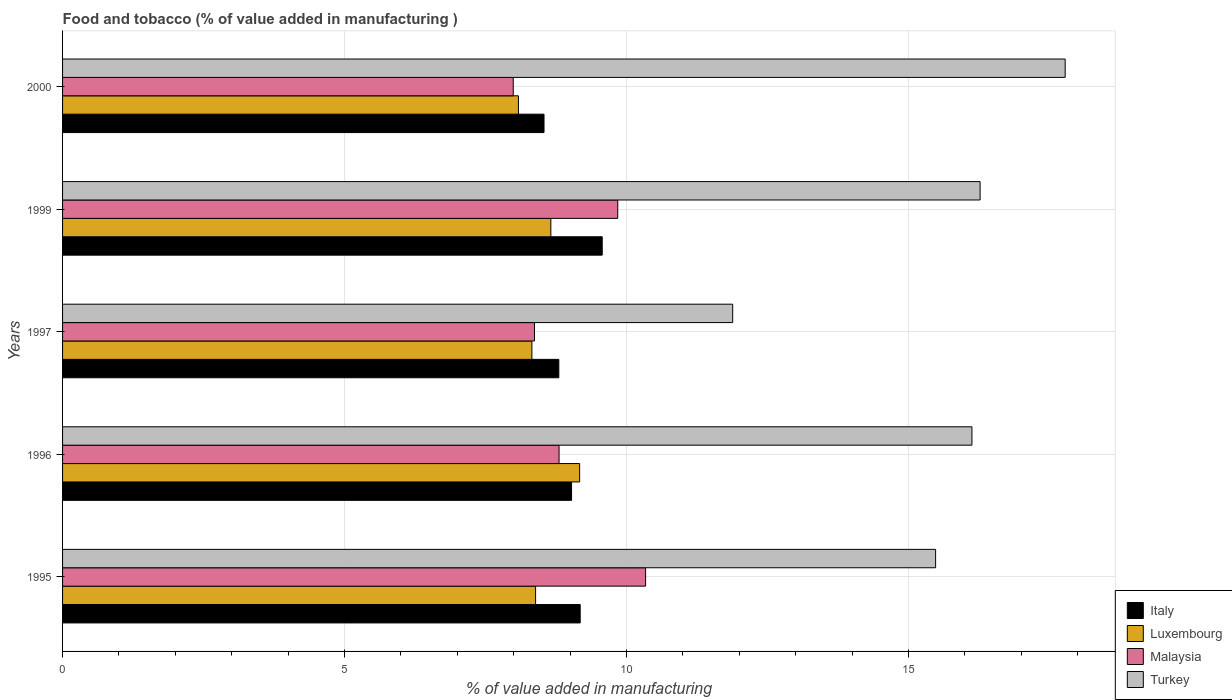How many different coloured bars are there?
Give a very brief answer. 4. How many groups of bars are there?
Offer a terse response. 5. Are the number of bars per tick equal to the number of legend labels?
Your answer should be very brief. Yes. How many bars are there on the 4th tick from the top?
Offer a very short reply. 4. How many bars are there on the 3rd tick from the bottom?
Your answer should be compact. 4. In how many cases, is the number of bars for a given year not equal to the number of legend labels?
Give a very brief answer. 0. What is the value added in manufacturing food and tobacco in Turkey in 1996?
Make the answer very short. 16.12. Across all years, what is the maximum value added in manufacturing food and tobacco in Italy?
Your answer should be compact. 9.57. Across all years, what is the minimum value added in manufacturing food and tobacco in Luxembourg?
Keep it short and to the point. 8.08. What is the total value added in manufacturing food and tobacco in Turkey in the graph?
Offer a terse response. 77.54. What is the difference between the value added in manufacturing food and tobacco in Italy in 1997 and that in 1999?
Your answer should be very brief. -0.77. What is the difference between the value added in manufacturing food and tobacco in Malaysia in 2000 and the value added in manufacturing food and tobacco in Turkey in 1995?
Your response must be concise. -7.49. What is the average value added in manufacturing food and tobacco in Turkey per year?
Ensure brevity in your answer.  15.51. In the year 1997, what is the difference between the value added in manufacturing food and tobacco in Turkey and value added in manufacturing food and tobacco in Luxembourg?
Offer a terse response. 3.56. What is the ratio of the value added in manufacturing food and tobacco in Luxembourg in 1996 to that in 1999?
Provide a succinct answer. 1.06. What is the difference between the highest and the second highest value added in manufacturing food and tobacco in Luxembourg?
Provide a succinct answer. 0.51. What is the difference between the highest and the lowest value added in manufacturing food and tobacco in Malaysia?
Keep it short and to the point. 2.35. What does the 2nd bar from the top in 1997 represents?
Provide a short and direct response. Malaysia. Are all the bars in the graph horizontal?
Provide a succinct answer. Yes. Are the values on the major ticks of X-axis written in scientific E-notation?
Ensure brevity in your answer.  No. Does the graph contain any zero values?
Provide a short and direct response. No. Does the graph contain grids?
Make the answer very short. Yes. Where does the legend appear in the graph?
Your answer should be compact. Bottom right. What is the title of the graph?
Your answer should be compact. Food and tobacco (% of value added in manufacturing ). Does "Dominica" appear as one of the legend labels in the graph?
Make the answer very short. No. What is the label or title of the X-axis?
Give a very brief answer. % of value added in manufacturing. What is the label or title of the Y-axis?
Ensure brevity in your answer.  Years. What is the % of value added in manufacturing of Italy in 1995?
Your answer should be compact. 9.18. What is the % of value added in manufacturing in Luxembourg in 1995?
Ensure brevity in your answer.  8.39. What is the % of value added in manufacturing of Malaysia in 1995?
Keep it short and to the point. 10.34. What is the % of value added in manufacturing in Turkey in 1995?
Your answer should be compact. 15.48. What is the % of value added in manufacturing in Italy in 1996?
Your answer should be compact. 9.03. What is the % of value added in manufacturing in Luxembourg in 1996?
Offer a terse response. 9.17. What is the % of value added in manufacturing of Malaysia in 1996?
Provide a succinct answer. 8.8. What is the % of value added in manufacturing of Turkey in 1996?
Ensure brevity in your answer.  16.12. What is the % of value added in manufacturing in Italy in 1997?
Make the answer very short. 8.8. What is the % of value added in manufacturing in Luxembourg in 1997?
Provide a succinct answer. 8.32. What is the % of value added in manufacturing of Malaysia in 1997?
Offer a very short reply. 8.37. What is the % of value added in manufacturing of Turkey in 1997?
Your answer should be very brief. 11.88. What is the % of value added in manufacturing in Italy in 1999?
Your answer should be compact. 9.57. What is the % of value added in manufacturing of Luxembourg in 1999?
Ensure brevity in your answer.  8.66. What is the % of value added in manufacturing of Malaysia in 1999?
Ensure brevity in your answer.  9.84. What is the % of value added in manufacturing of Turkey in 1999?
Provide a succinct answer. 16.27. What is the % of value added in manufacturing in Italy in 2000?
Your answer should be very brief. 8.54. What is the % of value added in manufacturing of Luxembourg in 2000?
Make the answer very short. 8.08. What is the % of value added in manufacturing in Malaysia in 2000?
Make the answer very short. 7.99. What is the % of value added in manufacturing of Turkey in 2000?
Your response must be concise. 17.78. Across all years, what is the maximum % of value added in manufacturing in Italy?
Provide a succinct answer. 9.57. Across all years, what is the maximum % of value added in manufacturing in Luxembourg?
Keep it short and to the point. 9.17. Across all years, what is the maximum % of value added in manufacturing in Malaysia?
Offer a very short reply. 10.34. Across all years, what is the maximum % of value added in manufacturing in Turkey?
Provide a short and direct response. 17.78. Across all years, what is the minimum % of value added in manufacturing of Italy?
Ensure brevity in your answer.  8.54. Across all years, what is the minimum % of value added in manufacturing of Luxembourg?
Your answer should be very brief. 8.08. Across all years, what is the minimum % of value added in manufacturing in Malaysia?
Keep it short and to the point. 7.99. Across all years, what is the minimum % of value added in manufacturing of Turkey?
Ensure brevity in your answer.  11.88. What is the total % of value added in manufacturing of Italy in the graph?
Your answer should be compact. 45.11. What is the total % of value added in manufacturing in Luxembourg in the graph?
Provide a succinct answer. 42.62. What is the total % of value added in manufacturing in Malaysia in the graph?
Your answer should be compact. 45.35. What is the total % of value added in manufacturing in Turkey in the graph?
Offer a very short reply. 77.54. What is the difference between the % of value added in manufacturing in Italy in 1995 and that in 1996?
Offer a terse response. 0.15. What is the difference between the % of value added in manufacturing of Luxembourg in 1995 and that in 1996?
Ensure brevity in your answer.  -0.78. What is the difference between the % of value added in manufacturing in Malaysia in 1995 and that in 1996?
Your answer should be compact. 1.53. What is the difference between the % of value added in manufacturing in Turkey in 1995 and that in 1996?
Provide a succinct answer. -0.64. What is the difference between the % of value added in manufacturing of Italy in 1995 and that in 1997?
Ensure brevity in your answer.  0.38. What is the difference between the % of value added in manufacturing of Luxembourg in 1995 and that in 1997?
Give a very brief answer. 0.07. What is the difference between the % of value added in manufacturing in Malaysia in 1995 and that in 1997?
Give a very brief answer. 1.97. What is the difference between the % of value added in manufacturing of Turkey in 1995 and that in 1997?
Make the answer very short. 3.6. What is the difference between the % of value added in manufacturing of Italy in 1995 and that in 1999?
Provide a short and direct response. -0.39. What is the difference between the % of value added in manufacturing of Luxembourg in 1995 and that in 1999?
Give a very brief answer. -0.27. What is the difference between the % of value added in manufacturing of Malaysia in 1995 and that in 1999?
Offer a very short reply. 0.49. What is the difference between the % of value added in manufacturing in Turkey in 1995 and that in 1999?
Offer a very short reply. -0.79. What is the difference between the % of value added in manufacturing of Italy in 1995 and that in 2000?
Give a very brief answer. 0.64. What is the difference between the % of value added in manufacturing in Luxembourg in 1995 and that in 2000?
Your answer should be very brief. 0.3. What is the difference between the % of value added in manufacturing in Malaysia in 1995 and that in 2000?
Make the answer very short. 2.35. What is the difference between the % of value added in manufacturing of Turkey in 1995 and that in 2000?
Your answer should be compact. -2.3. What is the difference between the % of value added in manufacturing in Italy in 1996 and that in 1997?
Keep it short and to the point. 0.23. What is the difference between the % of value added in manufacturing of Luxembourg in 1996 and that in 1997?
Provide a short and direct response. 0.85. What is the difference between the % of value added in manufacturing of Malaysia in 1996 and that in 1997?
Your response must be concise. 0.44. What is the difference between the % of value added in manufacturing in Turkey in 1996 and that in 1997?
Offer a very short reply. 4.24. What is the difference between the % of value added in manufacturing in Italy in 1996 and that in 1999?
Your answer should be very brief. -0.54. What is the difference between the % of value added in manufacturing of Luxembourg in 1996 and that in 1999?
Your answer should be compact. 0.51. What is the difference between the % of value added in manufacturing of Malaysia in 1996 and that in 1999?
Your response must be concise. -1.04. What is the difference between the % of value added in manufacturing in Turkey in 1996 and that in 1999?
Your answer should be compact. -0.14. What is the difference between the % of value added in manufacturing of Italy in 1996 and that in 2000?
Your answer should be compact. 0.49. What is the difference between the % of value added in manufacturing of Luxembourg in 1996 and that in 2000?
Offer a very short reply. 1.09. What is the difference between the % of value added in manufacturing in Malaysia in 1996 and that in 2000?
Your response must be concise. 0.81. What is the difference between the % of value added in manufacturing of Turkey in 1996 and that in 2000?
Ensure brevity in your answer.  -1.65. What is the difference between the % of value added in manufacturing of Italy in 1997 and that in 1999?
Make the answer very short. -0.77. What is the difference between the % of value added in manufacturing of Luxembourg in 1997 and that in 1999?
Your answer should be compact. -0.34. What is the difference between the % of value added in manufacturing in Malaysia in 1997 and that in 1999?
Make the answer very short. -1.48. What is the difference between the % of value added in manufacturing in Turkey in 1997 and that in 1999?
Your response must be concise. -4.39. What is the difference between the % of value added in manufacturing of Italy in 1997 and that in 2000?
Your response must be concise. 0.26. What is the difference between the % of value added in manufacturing in Luxembourg in 1997 and that in 2000?
Provide a succinct answer. 0.24. What is the difference between the % of value added in manufacturing of Malaysia in 1997 and that in 2000?
Ensure brevity in your answer.  0.38. What is the difference between the % of value added in manufacturing of Turkey in 1997 and that in 2000?
Provide a short and direct response. -5.9. What is the difference between the % of value added in manufacturing in Italy in 1999 and that in 2000?
Keep it short and to the point. 1.03. What is the difference between the % of value added in manufacturing in Luxembourg in 1999 and that in 2000?
Make the answer very short. 0.57. What is the difference between the % of value added in manufacturing in Malaysia in 1999 and that in 2000?
Offer a terse response. 1.85. What is the difference between the % of value added in manufacturing in Turkey in 1999 and that in 2000?
Give a very brief answer. -1.51. What is the difference between the % of value added in manufacturing of Italy in 1995 and the % of value added in manufacturing of Luxembourg in 1996?
Your response must be concise. 0.01. What is the difference between the % of value added in manufacturing of Italy in 1995 and the % of value added in manufacturing of Malaysia in 1996?
Your answer should be very brief. 0.37. What is the difference between the % of value added in manufacturing in Italy in 1995 and the % of value added in manufacturing in Turkey in 1996?
Your response must be concise. -6.95. What is the difference between the % of value added in manufacturing in Luxembourg in 1995 and the % of value added in manufacturing in Malaysia in 1996?
Your answer should be compact. -0.42. What is the difference between the % of value added in manufacturing of Luxembourg in 1995 and the % of value added in manufacturing of Turkey in 1996?
Keep it short and to the point. -7.74. What is the difference between the % of value added in manufacturing in Malaysia in 1995 and the % of value added in manufacturing in Turkey in 1996?
Your response must be concise. -5.79. What is the difference between the % of value added in manufacturing in Italy in 1995 and the % of value added in manufacturing in Luxembourg in 1997?
Your response must be concise. 0.86. What is the difference between the % of value added in manufacturing of Italy in 1995 and the % of value added in manufacturing of Malaysia in 1997?
Provide a short and direct response. 0.81. What is the difference between the % of value added in manufacturing of Italy in 1995 and the % of value added in manufacturing of Turkey in 1997?
Give a very brief answer. -2.7. What is the difference between the % of value added in manufacturing of Luxembourg in 1995 and the % of value added in manufacturing of Malaysia in 1997?
Ensure brevity in your answer.  0.02. What is the difference between the % of value added in manufacturing in Luxembourg in 1995 and the % of value added in manufacturing in Turkey in 1997?
Offer a very short reply. -3.5. What is the difference between the % of value added in manufacturing in Malaysia in 1995 and the % of value added in manufacturing in Turkey in 1997?
Make the answer very short. -1.54. What is the difference between the % of value added in manufacturing in Italy in 1995 and the % of value added in manufacturing in Luxembourg in 1999?
Your answer should be very brief. 0.52. What is the difference between the % of value added in manufacturing in Italy in 1995 and the % of value added in manufacturing in Malaysia in 1999?
Offer a terse response. -0.67. What is the difference between the % of value added in manufacturing of Italy in 1995 and the % of value added in manufacturing of Turkey in 1999?
Keep it short and to the point. -7.09. What is the difference between the % of value added in manufacturing of Luxembourg in 1995 and the % of value added in manufacturing of Malaysia in 1999?
Provide a short and direct response. -1.46. What is the difference between the % of value added in manufacturing of Luxembourg in 1995 and the % of value added in manufacturing of Turkey in 1999?
Ensure brevity in your answer.  -7.88. What is the difference between the % of value added in manufacturing in Malaysia in 1995 and the % of value added in manufacturing in Turkey in 1999?
Ensure brevity in your answer.  -5.93. What is the difference between the % of value added in manufacturing in Italy in 1995 and the % of value added in manufacturing in Luxembourg in 2000?
Give a very brief answer. 1.09. What is the difference between the % of value added in manufacturing in Italy in 1995 and the % of value added in manufacturing in Malaysia in 2000?
Give a very brief answer. 1.19. What is the difference between the % of value added in manufacturing in Italy in 1995 and the % of value added in manufacturing in Turkey in 2000?
Offer a terse response. -8.6. What is the difference between the % of value added in manufacturing in Luxembourg in 1995 and the % of value added in manufacturing in Malaysia in 2000?
Keep it short and to the point. 0.4. What is the difference between the % of value added in manufacturing of Luxembourg in 1995 and the % of value added in manufacturing of Turkey in 2000?
Provide a succinct answer. -9.39. What is the difference between the % of value added in manufacturing in Malaysia in 1995 and the % of value added in manufacturing in Turkey in 2000?
Your response must be concise. -7.44. What is the difference between the % of value added in manufacturing of Italy in 1996 and the % of value added in manufacturing of Luxembourg in 1997?
Ensure brevity in your answer.  0.7. What is the difference between the % of value added in manufacturing of Italy in 1996 and the % of value added in manufacturing of Malaysia in 1997?
Give a very brief answer. 0.66. What is the difference between the % of value added in manufacturing in Italy in 1996 and the % of value added in manufacturing in Turkey in 1997?
Give a very brief answer. -2.86. What is the difference between the % of value added in manufacturing in Luxembourg in 1996 and the % of value added in manufacturing in Malaysia in 1997?
Your answer should be compact. 0.8. What is the difference between the % of value added in manufacturing of Luxembourg in 1996 and the % of value added in manufacturing of Turkey in 1997?
Keep it short and to the point. -2.71. What is the difference between the % of value added in manufacturing in Malaysia in 1996 and the % of value added in manufacturing in Turkey in 1997?
Give a very brief answer. -3.08. What is the difference between the % of value added in manufacturing of Italy in 1996 and the % of value added in manufacturing of Luxembourg in 1999?
Provide a short and direct response. 0.37. What is the difference between the % of value added in manufacturing in Italy in 1996 and the % of value added in manufacturing in Malaysia in 1999?
Offer a terse response. -0.82. What is the difference between the % of value added in manufacturing in Italy in 1996 and the % of value added in manufacturing in Turkey in 1999?
Make the answer very short. -7.24. What is the difference between the % of value added in manufacturing of Luxembourg in 1996 and the % of value added in manufacturing of Malaysia in 1999?
Your answer should be compact. -0.68. What is the difference between the % of value added in manufacturing of Luxembourg in 1996 and the % of value added in manufacturing of Turkey in 1999?
Your answer should be very brief. -7.1. What is the difference between the % of value added in manufacturing in Malaysia in 1996 and the % of value added in manufacturing in Turkey in 1999?
Make the answer very short. -7.47. What is the difference between the % of value added in manufacturing in Italy in 1996 and the % of value added in manufacturing in Luxembourg in 2000?
Give a very brief answer. 0.94. What is the difference between the % of value added in manufacturing of Italy in 1996 and the % of value added in manufacturing of Malaysia in 2000?
Your answer should be compact. 1.03. What is the difference between the % of value added in manufacturing of Italy in 1996 and the % of value added in manufacturing of Turkey in 2000?
Your answer should be compact. -8.75. What is the difference between the % of value added in manufacturing of Luxembourg in 1996 and the % of value added in manufacturing of Malaysia in 2000?
Offer a very short reply. 1.18. What is the difference between the % of value added in manufacturing of Luxembourg in 1996 and the % of value added in manufacturing of Turkey in 2000?
Keep it short and to the point. -8.61. What is the difference between the % of value added in manufacturing of Malaysia in 1996 and the % of value added in manufacturing of Turkey in 2000?
Ensure brevity in your answer.  -8.97. What is the difference between the % of value added in manufacturing in Italy in 1997 and the % of value added in manufacturing in Luxembourg in 1999?
Give a very brief answer. 0.14. What is the difference between the % of value added in manufacturing in Italy in 1997 and the % of value added in manufacturing in Malaysia in 1999?
Offer a very short reply. -1.05. What is the difference between the % of value added in manufacturing in Italy in 1997 and the % of value added in manufacturing in Turkey in 1999?
Your answer should be compact. -7.47. What is the difference between the % of value added in manufacturing in Luxembourg in 1997 and the % of value added in manufacturing in Malaysia in 1999?
Your answer should be very brief. -1.52. What is the difference between the % of value added in manufacturing in Luxembourg in 1997 and the % of value added in manufacturing in Turkey in 1999?
Make the answer very short. -7.95. What is the difference between the % of value added in manufacturing in Malaysia in 1997 and the % of value added in manufacturing in Turkey in 1999?
Provide a short and direct response. -7.9. What is the difference between the % of value added in manufacturing of Italy in 1997 and the % of value added in manufacturing of Luxembourg in 2000?
Provide a succinct answer. 0.72. What is the difference between the % of value added in manufacturing of Italy in 1997 and the % of value added in manufacturing of Malaysia in 2000?
Ensure brevity in your answer.  0.81. What is the difference between the % of value added in manufacturing in Italy in 1997 and the % of value added in manufacturing in Turkey in 2000?
Your response must be concise. -8.98. What is the difference between the % of value added in manufacturing of Luxembourg in 1997 and the % of value added in manufacturing of Malaysia in 2000?
Provide a succinct answer. 0.33. What is the difference between the % of value added in manufacturing in Luxembourg in 1997 and the % of value added in manufacturing in Turkey in 2000?
Give a very brief answer. -9.46. What is the difference between the % of value added in manufacturing in Malaysia in 1997 and the % of value added in manufacturing in Turkey in 2000?
Give a very brief answer. -9.41. What is the difference between the % of value added in manufacturing of Italy in 1999 and the % of value added in manufacturing of Luxembourg in 2000?
Your answer should be very brief. 1.49. What is the difference between the % of value added in manufacturing of Italy in 1999 and the % of value added in manufacturing of Malaysia in 2000?
Keep it short and to the point. 1.58. What is the difference between the % of value added in manufacturing of Italy in 1999 and the % of value added in manufacturing of Turkey in 2000?
Provide a succinct answer. -8.21. What is the difference between the % of value added in manufacturing in Luxembourg in 1999 and the % of value added in manufacturing in Malaysia in 2000?
Give a very brief answer. 0.67. What is the difference between the % of value added in manufacturing of Luxembourg in 1999 and the % of value added in manufacturing of Turkey in 2000?
Your response must be concise. -9.12. What is the difference between the % of value added in manufacturing in Malaysia in 1999 and the % of value added in manufacturing in Turkey in 2000?
Your response must be concise. -7.93. What is the average % of value added in manufacturing of Italy per year?
Your answer should be compact. 9.02. What is the average % of value added in manufacturing of Luxembourg per year?
Your answer should be compact. 8.52. What is the average % of value added in manufacturing in Malaysia per year?
Make the answer very short. 9.07. What is the average % of value added in manufacturing in Turkey per year?
Keep it short and to the point. 15.51. In the year 1995, what is the difference between the % of value added in manufacturing of Italy and % of value added in manufacturing of Luxembourg?
Keep it short and to the point. 0.79. In the year 1995, what is the difference between the % of value added in manufacturing in Italy and % of value added in manufacturing in Malaysia?
Your answer should be very brief. -1.16. In the year 1995, what is the difference between the % of value added in manufacturing in Italy and % of value added in manufacturing in Turkey?
Make the answer very short. -6.3. In the year 1995, what is the difference between the % of value added in manufacturing in Luxembourg and % of value added in manufacturing in Malaysia?
Ensure brevity in your answer.  -1.95. In the year 1995, what is the difference between the % of value added in manufacturing in Luxembourg and % of value added in manufacturing in Turkey?
Provide a succinct answer. -7.09. In the year 1995, what is the difference between the % of value added in manufacturing of Malaysia and % of value added in manufacturing of Turkey?
Provide a succinct answer. -5.14. In the year 1996, what is the difference between the % of value added in manufacturing of Italy and % of value added in manufacturing of Luxembourg?
Your answer should be very brief. -0.14. In the year 1996, what is the difference between the % of value added in manufacturing of Italy and % of value added in manufacturing of Malaysia?
Your response must be concise. 0.22. In the year 1996, what is the difference between the % of value added in manufacturing of Italy and % of value added in manufacturing of Turkey?
Make the answer very short. -7.1. In the year 1996, what is the difference between the % of value added in manufacturing of Luxembourg and % of value added in manufacturing of Malaysia?
Provide a succinct answer. 0.36. In the year 1996, what is the difference between the % of value added in manufacturing of Luxembourg and % of value added in manufacturing of Turkey?
Offer a very short reply. -6.96. In the year 1996, what is the difference between the % of value added in manufacturing of Malaysia and % of value added in manufacturing of Turkey?
Offer a terse response. -7.32. In the year 1997, what is the difference between the % of value added in manufacturing in Italy and % of value added in manufacturing in Luxembourg?
Your response must be concise. 0.48. In the year 1997, what is the difference between the % of value added in manufacturing of Italy and % of value added in manufacturing of Malaysia?
Provide a succinct answer. 0.43. In the year 1997, what is the difference between the % of value added in manufacturing in Italy and % of value added in manufacturing in Turkey?
Your response must be concise. -3.08. In the year 1997, what is the difference between the % of value added in manufacturing of Luxembourg and % of value added in manufacturing of Malaysia?
Your answer should be compact. -0.05. In the year 1997, what is the difference between the % of value added in manufacturing of Luxembourg and % of value added in manufacturing of Turkey?
Offer a terse response. -3.56. In the year 1997, what is the difference between the % of value added in manufacturing in Malaysia and % of value added in manufacturing in Turkey?
Provide a short and direct response. -3.51. In the year 1999, what is the difference between the % of value added in manufacturing of Italy and % of value added in manufacturing of Luxembourg?
Make the answer very short. 0.91. In the year 1999, what is the difference between the % of value added in manufacturing in Italy and % of value added in manufacturing in Malaysia?
Offer a very short reply. -0.28. In the year 1999, what is the difference between the % of value added in manufacturing in Italy and % of value added in manufacturing in Turkey?
Your answer should be very brief. -6.7. In the year 1999, what is the difference between the % of value added in manufacturing of Luxembourg and % of value added in manufacturing of Malaysia?
Your answer should be very brief. -1.19. In the year 1999, what is the difference between the % of value added in manufacturing of Luxembourg and % of value added in manufacturing of Turkey?
Keep it short and to the point. -7.61. In the year 1999, what is the difference between the % of value added in manufacturing of Malaysia and % of value added in manufacturing of Turkey?
Give a very brief answer. -6.43. In the year 2000, what is the difference between the % of value added in manufacturing of Italy and % of value added in manufacturing of Luxembourg?
Ensure brevity in your answer.  0.45. In the year 2000, what is the difference between the % of value added in manufacturing of Italy and % of value added in manufacturing of Malaysia?
Provide a short and direct response. 0.55. In the year 2000, what is the difference between the % of value added in manufacturing of Italy and % of value added in manufacturing of Turkey?
Ensure brevity in your answer.  -9.24. In the year 2000, what is the difference between the % of value added in manufacturing in Luxembourg and % of value added in manufacturing in Malaysia?
Your answer should be compact. 0.09. In the year 2000, what is the difference between the % of value added in manufacturing in Luxembourg and % of value added in manufacturing in Turkey?
Keep it short and to the point. -9.69. In the year 2000, what is the difference between the % of value added in manufacturing of Malaysia and % of value added in manufacturing of Turkey?
Your response must be concise. -9.79. What is the ratio of the % of value added in manufacturing in Italy in 1995 to that in 1996?
Ensure brevity in your answer.  1.02. What is the ratio of the % of value added in manufacturing of Luxembourg in 1995 to that in 1996?
Ensure brevity in your answer.  0.91. What is the ratio of the % of value added in manufacturing in Malaysia in 1995 to that in 1996?
Provide a succinct answer. 1.17. What is the ratio of the % of value added in manufacturing of Turkey in 1995 to that in 1996?
Make the answer very short. 0.96. What is the ratio of the % of value added in manufacturing of Italy in 1995 to that in 1997?
Ensure brevity in your answer.  1.04. What is the ratio of the % of value added in manufacturing in Luxembourg in 1995 to that in 1997?
Make the answer very short. 1.01. What is the ratio of the % of value added in manufacturing in Malaysia in 1995 to that in 1997?
Ensure brevity in your answer.  1.24. What is the ratio of the % of value added in manufacturing in Turkey in 1995 to that in 1997?
Provide a succinct answer. 1.3. What is the ratio of the % of value added in manufacturing in Italy in 1995 to that in 1999?
Offer a very short reply. 0.96. What is the ratio of the % of value added in manufacturing of Luxembourg in 1995 to that in 1999?
Your answer should be very brief. 0.97. What is the ratio of the % of value added in manufacturing of Malaysia in 1995 to that in 1999?
Offer a very short reply. 1.05. What is the ratio of the % of value added in manufacturing in Turkey in 1995 to that in 1999?
Provide a short and direct response. 0.95. What is the ratio of the % of value added in manufacturing of Italy in 1995 to that in 2000?
Make the answer very short. 1.08. What is the ratio of the % of value added in manufacturing in Luxembourg in 1995 to that in 2000?
Provide a short and direct response. 1.04. What is the ratio of the % of value added in manufacturing of Malaysia in 1995 to that in 2000?
Your response must be concise. 1.29. What is the ratio of the % of value added in manufacturing of Turkey in 1995 to that in 2000?
Offer a terse response. 0.87. What is the ratio of the % of value added in manufacturing in Italy in 1996 to that in 1997?
Your answer should be compact. 1.03. What is the ratio of the % of value added in manufacturing of Luxembourg in 1996 to that in 1997?
Give a very brief answer. 1.1. What is the ratio of the % of value added in manufacturing in Malaysia in 1996 to that in 1997?
Your response must be concise. 1.05. What is the ratio of the % of value added in manufacturing in Turkey in 1996 to that in 1997?
Provide a succinct answer. 1.36. What is the ratio of the % of value added in manufacturing of Italy in 1996 to that in 1999?
Your response must be concise. 0.94. What is the ratio of the % of value added in manufacturing of Luxembourg in 1996 to that in 1999?
Keep it short and to the point. 1.06. What is the ratio of the % of value added in manufacturing in Malaysia in 1996 to that in 1999?
Offer a very short reply. 0.89. What is the ratio of the % of value added in manufacturing of Turkey in 1996 to that in 1999?
Your answer should be very brief. 0.99. What is the ratio of the % of value added in manufacturing in Italy in 1996 to that in 2000?
Keep it short and to the point. 1.06. What is the ratio of the % of value added in manufacturing of Luxembourg in 1996 to that in 2000?
Your answer should be very brief. 1.13. What is the ratio of the % of value added in manufacturing in Malaysia in 1996 to that in 2000?
Your answer should be compact. 1.1. What is the ratio of the % of value added in manufacturing of Turkey in 1996 to that in 2000?
Keep it short and to the point. 0.91. What is the ratio of the % of value added in manufacturing in Italy in 1997 to that in 1999?
Your response must be concise. 0.92. What is the ratio of the % of value added in manufacturing in Luxembourg in 1997 to that in 1999?
Ensure brevity in your answer.  0.96. What is the ratio of the % of value added in manufacturing in Turkey in 1997 to that in 1999?
Give a very brief answer. 0.73. What is the ratio of the % of value added in manufacturing of Italy in 1997 to that in 2000?
Your response must be concise. 1.03. What is the ratio of the % of value added in manufacturing of Luxembourg in 1997 to that in 2000?
Provide a succinct answer. 1.03. What is the ratio of the % of value added in manufacturing of Malaysia in 1997 to that in 2000?
Ensure brevity in your answer.  1.05. What is the ratio of the % of value added in manufacturing in Turkey in 1997 to that in 2000?
Your answer should be compact. 0.67. What is the ratio of the % of value added in manufacturing in Italy in 1999 to that in 2000?
Your response must be concise. 1.12. What is the ratio of the % of value added in manufacturing in Luxembourg in 1999 to that in 2000?
Your answer should be very brief. 1.07. What is the ratio of the % of value added in manufacturing of Malaysia in 1999 to that in 2000?
Offer a very short reply. 1.23. What is the ratio of the % of value added in manufacturing in Turkey in 1999 to that in 2000?
Provide a succinct answer. 0.92. What is the difference between the highest and the second highest % of value added in manufacturing of Italy?
Ensure brevity in your answer.  0.39. What is the difference between the highest and the second highest % of value added in manufacturing in Luxembourg?
Ensure brevity in your answer.  0.51. What is the difference between the highest and the second highest % of value added in manufacturing in Malaysia?
Your answer should be very brief. 0.49. What is the difference between the highest and the second highest % of value added in manufacturing in Turkey?
Offer a terse response. 1.51. What is the difference between the highest and the lowest % of value added in manufacturing of Italy?
Provide a short and direct response. 1.03. What is the difference between the highest and the lowest % of value added in manufacturing of Luxembourg?
Make the answer very short. 1.09. What is the difference between the highest and the lowest % of value added in manufacturing in Malaysia?
Offer a terse response. 2.35. What is the difference between the highest and the lowest % of value added in manufacturing of Turkey?
Give a very brief answer. 5.9. 